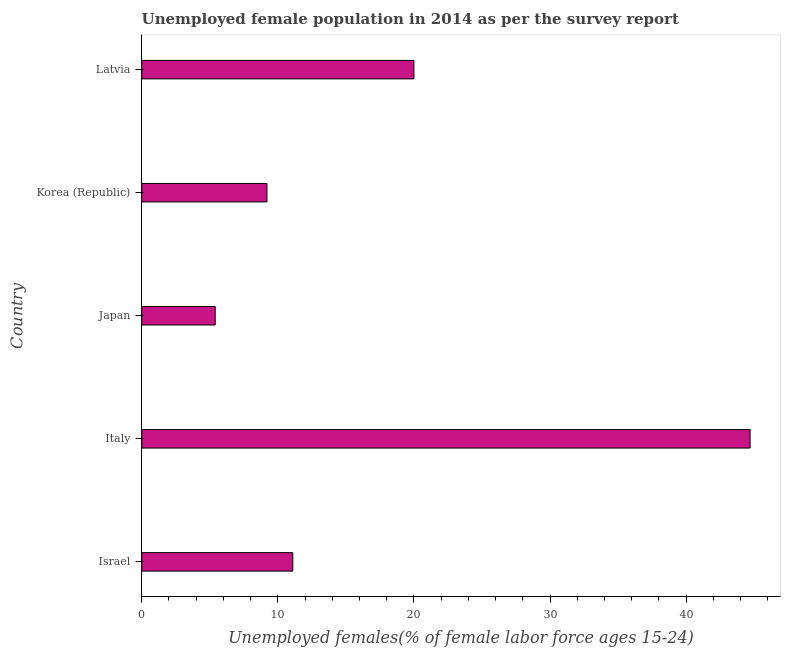What is the title of the graph?
Offer a very short reply. Unemployed female population in 2014 as per the survey report. What is the label or title of the X-axis?
Give a very brief answer. Unemployed females(% of female labor force ages 15-24). What is the unemployed female youth in Japan?
Make the answer very short. 5.4. Across all countries, what is the maximum unemployed female youth?
Keep it short and to the point. 44.7. Across all countries, what is the minimum unemployed female youth?
Keep it short and to the point. 5.4. In which country was the unemployed female youth minimum?
Make the answer very short. Japan. What is the sum of the unemployed female youth?
Your response must be concise. 90.4. What is the difference between the unemployed female youth in Italy and Latvia?
Your answer should be compact. 24.7. What is the average unemployed female youth per country?
Offer a terse response. 18.08. What is the median unemployed female youth?
Your response must be concise. 11.1. In how many countries, is the unemployed female youth greater than 4 %?
Make the answer very short. 5. What is the ratio of the unemployed female youth in Italy to that in Korea (Republic)?
Ensure brevity in your answer.  4.86. What is the difference between the highest and the second highest unemployed female youth?
Provide a short and direct response. 24.7. Is the sum of the unemployed female youth in Italy and Latvia greater than the maximum unemployed female youth across all countries?
Your answer should be compact. Yes. What is the difference between the highest and the lowest unemployed female youth?
Provide a short and direct response. 39.3. How many bars are there?
Offer a very short reply. 5. Are all the bars in the graph horizontal?
Your answer should be very brief. Yes. How many countries are there in the graph?
Keep it short and to the point. 5. What is the difference between two consecutive major ticks on the X-axis?
Keep it short and to the point. 10. What is the Unemployed females(% of female labor force ages 15-24) in Israel?
Make the answer very short. 11.1. What is the Unemployed females(% of female labor force ages 15-24) of Italy?
Keep it short and to the point. 44.7. What is the Unemployed females(% of female labor force ages 15-24) in Japan?
Keep it short and to the point. 5.4. What is the Unemployed females(% of female labor force ages 15-24) in Korea (Republic)?
Offer a very short reply. 9.2. What is the difference between the Unemployed females(% of female labor force ages 15-24) in Israel and Italy?
Make the answer very short. -33.6. What is the difference between the Unemployed females(% of female labor force ages 15-24) in Italy and Japan?
Provide a succinct answer. 39.3. What is the difference between the Unemployed females(% of female labor force ages 15-24) in Italy and Korea (Republic)?
Ensure brevity in your answer.  35.5. What is the difference between the Unemployed females(% of female labor force ages 15-24) in Italy and Latvia?
Make the answer very short. 24.7. What is the difference between the Unemployed females(% of female labor force ages 15-24) in Japan and Latvia?
Provide a succinct answer. -14.6. What is the ratio of the Unemployed females(% of female labor force ages 15-24) in Israel to that in Italy?
Provide a short and direct response. 0.25. What is the ratio of the Unemployed females(% of female labor force ages 15-24) in Israel to that in Japan?
Give a very brief answer. 2.06. What is the ratio of the Unemployed females(% of female labor force ages 15-24) in Israel to that in Korea (Republic)?
Provide a succinct answer. 1.21. What is the ratio of the Unemployed females(% of female labor force ages 15-24) in Israel to that in Latvia?
Offer a terse response. 0.56. What is the ratio of the Unemployed females(% of female labor force ages 15-24) in Italy to that in Japan?
Offer a terse response. 8.28. What is the ratio of the Unemployed females(% of female labor force ages 15-24) in Italy to that in Korea (Republic)?
Make the answer very short. 4.86. What is the ratio of the Unemployed females(% of female labor force ages 15-24) in Italy to that in Latvia?
Offer a very short reply. 2.23. What is the ratio of the Unemployed females(% of female labor force ages 15-24) in Japan to that in Korea (Republic)?
Keep it short and to the point. 0.59. What is the ratio of the Unemployed females(% of female labor force ages 15-24) in Japan to that in Latvia?
Provide a succinct answer. 0.27. What is the ratio of the Unemployed females(% of female labor force ages 15-24) in Korea (Republic) to that in Latvia?
Make the answer very short. 0.46. 